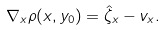Convert formula to latex. <formula><loc_0><loc_0><loc_500><loc_500>\nabla _ { x } \rho ( x , y _ { 0 } ) = \hat { \zeta } _ { x } - v _ { x } .</formula> 